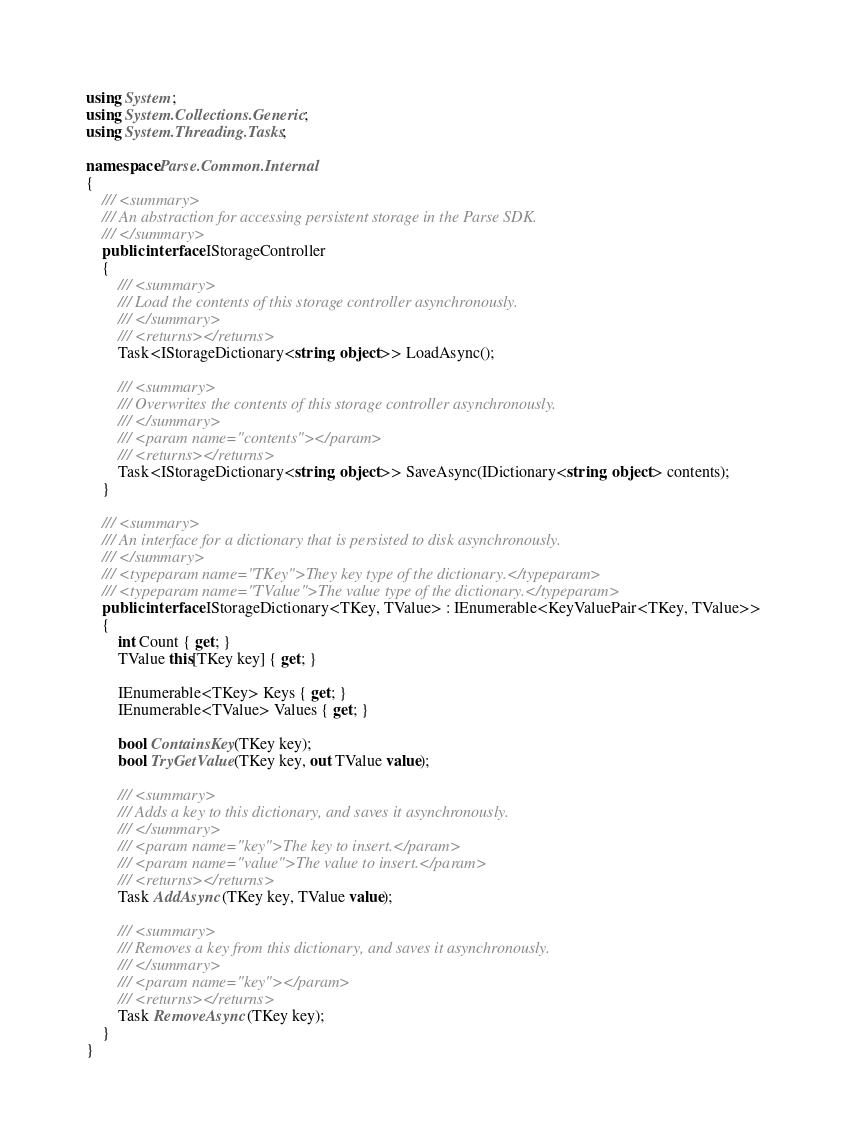Convert code to text. <code><loc_0><loc_0><loc_500><loc_500><_C#_>using System;
using System.Collections.Generic;
using System.Threading.Tasks;

namespace Parse.Common.Internal
{
    /// <summary>
    /// An abstraction for accessing persistent storage in the Parse SDK.
    /// </summary>
    public interface IStorageController
    {
        /// <summary>
        /// Load the contents of this storage controller asynchronously.
        /// </summary>
        /// <returns></returns>
        Task<IStorageDictionary<string, object>> LoadAsync();

        /// <summary>
        /// Overwrites the contents of this storage controller asynchronously.
        /// </summary>
        /// <param name="contents"></param>
        /// <returns></returns>
        Task<IStorageDictionary<string, object>> SaveAsync(IDictionary<string, object> contents);
    }

    /// <summary>
    /// An interface for a dictionary that is persisted to disk asynchronously.
    /// </summary>
    /// <typeparam name="TKey">They key type of the dictionary.</typeparam>
    /// <typeparam name="TValue">The value type of the dictionary.</typeparam>
    public interface IStorageDictionary<TKey, TValue> : IEnumerable<KeyValuePair<TKey, TValue>>
    {
        int Count { get; }
        TValue this[TKey key] { get; }

        IEnumerable<TKey> Keys { get; }
        IEnumerable<TValue> Values { get; }

        bool ContainsKey(TKey key);
        bool TryGetValue(TKey key, out TValue value);

        /// <summary>
        /// Adds a key to this dictionary, and saves it asynchronously.
        /// </summary>
        /// <param name="key">The key to insert.</param>
        /// <param name="value">The value to insert.</param>
        /// <returns></returns>
        Task AddAsync(TKey key, TValue value);

        /// <summary>
        /// Removes a key from this dictionary, and saves it asynchronously.
        /// </summary>
        /// <param name="key"></param>
        /// <returns></returns>
        Task RemoveAsync(TKey key);
    }
}</code> 